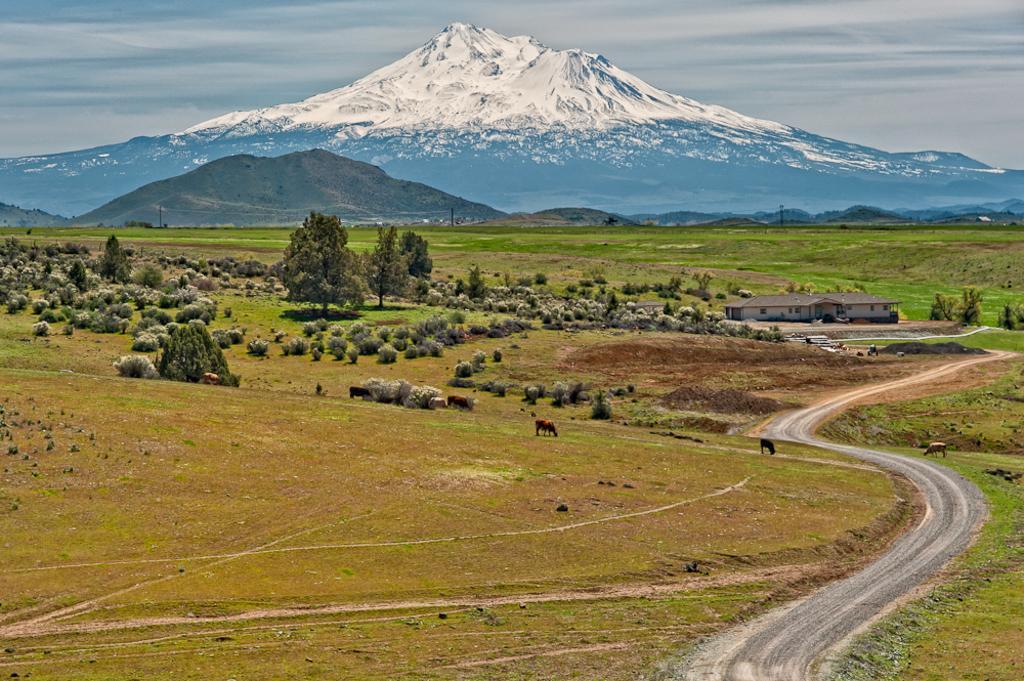Describe this image in one or two sentences. In this picture, we see cows grazing in the field. There are trees and building in white color. There are hills in the background. At the top of the picture, we see the sky. 